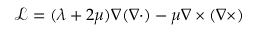<formula> <loc_0><loc_0><loc_500><loc_500>\mathcal { L } = ( \lambda + 2 \mu ) \nabla ( \nabla \cdot ) - \mu \nabla \times ( \nabla \times )</formula> 